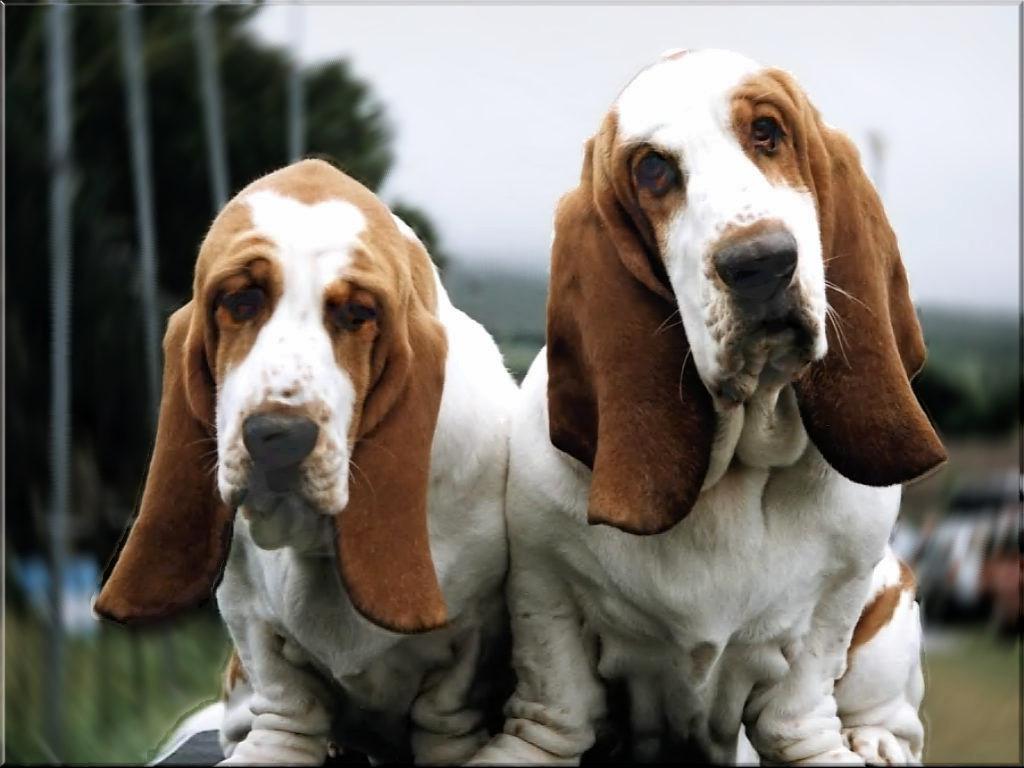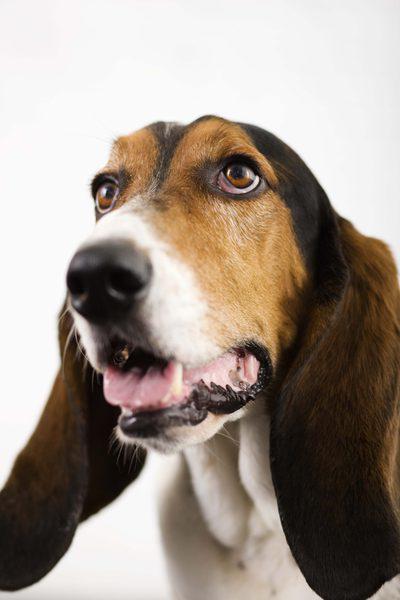The first image is the image on the left, the second image is the image on the right. Analyze the images presented: Is the assertion "Each photo contains a single dog." valid? Answer yes or no. No. The first image is the image on the left, the second image is the image on the right. Given the left and right images, does the statement "A non-collage image shows two animals side-by-side, at least one of them a basset hound." hold true? Answer yes or no. Yes. 